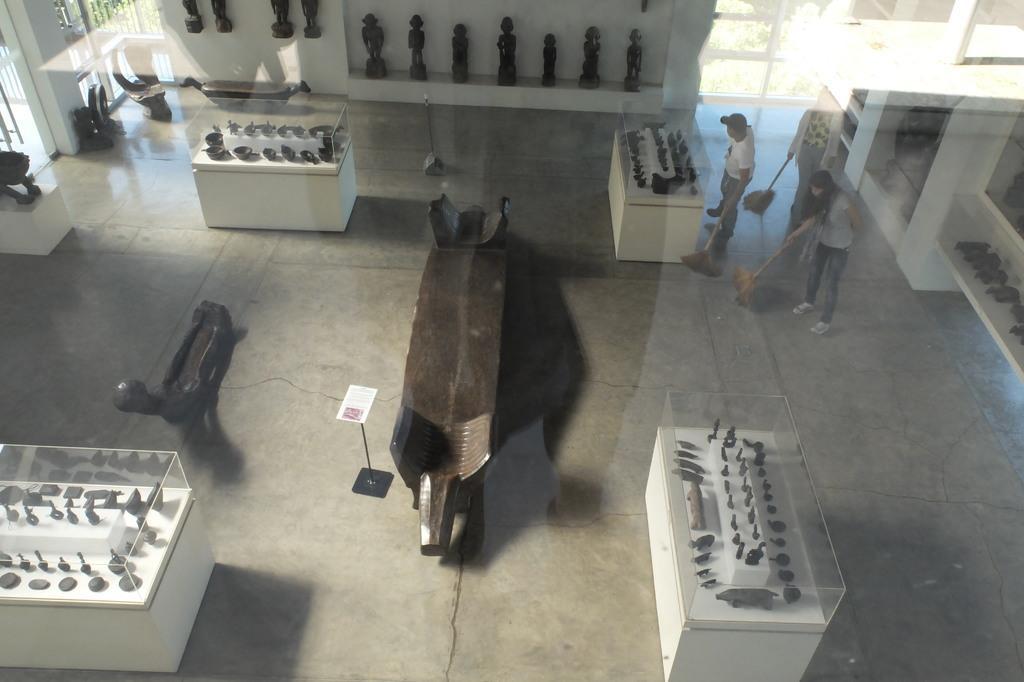In one or two sentences, can you explain what this image depicts? This image is clicked from a top view. It is clicked from behind a glass. On the other side of the glass there are tables on the floor. There are sculptures on the tables. The tables are covered with glass. There are a few people standing at the table. They are holding broom sticks in their hands. At the top there are shelves. There are sculptures in the shelves. There are glass doors to the wall. 